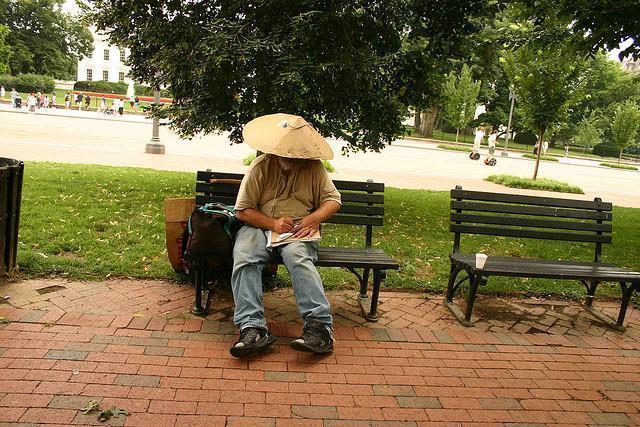What purpose does the large disk on this person's head serve most here?
Indicate the correct choice and explain in the format: 'Answer: answer
Rationale: rationale.'
Options: Rain protection, moon, sun, hiding. Answer: sun.
Rationale: It looks like an umbrella. 